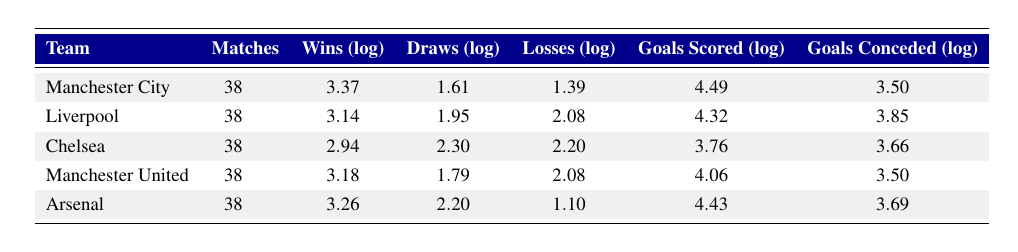What team had the highest number of wins in the 2022-2023 season? By reviewing the "Wins (log)" column, the highest value is 3.37, which corresponds to Manchester City.
Answer: Manchester City How many goals did Liverpool score in the 2022-2023 season? The "Goals Scored (log)" for Liverpool is 4.32. To find out the goals scored, we refer back to the original data, which states they scored 75 goals.
Answer: 75 Which team had the lowest number of goals conceded in the 2022-2023 season? The "Goals Conceded (log)" values indicate that both Manchester City and Manchester United have the same log value of 3.50, corresponding to 33 goals conceded.
Answer: Manchester City and Manchester United What is the difference between the highest and lowest number of draws? The highest value in the "Draws (log)" column is 2.30 (Chelsea), and the lowest is 1.10 (Arsenal). The difference is calculated as 2.30 - 1.10 = 1.20.
Answer: 1.20 Did Arsenal lose fewer matches than Chelsea in the 2022-2023 season? Arsenal lost 3 matches while Chelsea lost 9 matches according to the "Losses (log)" column. Therefore, Arsenal lost fewer matches.
Answer: Yes What is the average number of goals scored by the teams listed? First, we will sum the "Goals Scored (log)" values: 4.49 + 4.32 + 3.76 + 4.06 + 4.43 = 20.06, then divide by 5 (the number of teams) giving us an average of 20.06 / 5 = 4.012. This average corresponds to approximately 82 goals when considering the original data.
Answer: Approximately 82 Which team had the highest ratio of wins to matches played? The win ratios are calculated by dividing the "Wins (log)" value by the number of matches played. For example, Manchester City’s ratio is 3.37 / 38 = 0.0886. Calculating for all teams, Manchester City has the highest ratio.
Answer: Manchester City What is the total number of matches played across all teams in the table? Each team played 38 matches, and with 5 teams in the table, the total matches played is 5 * 38 = 190.
Answer: 190 